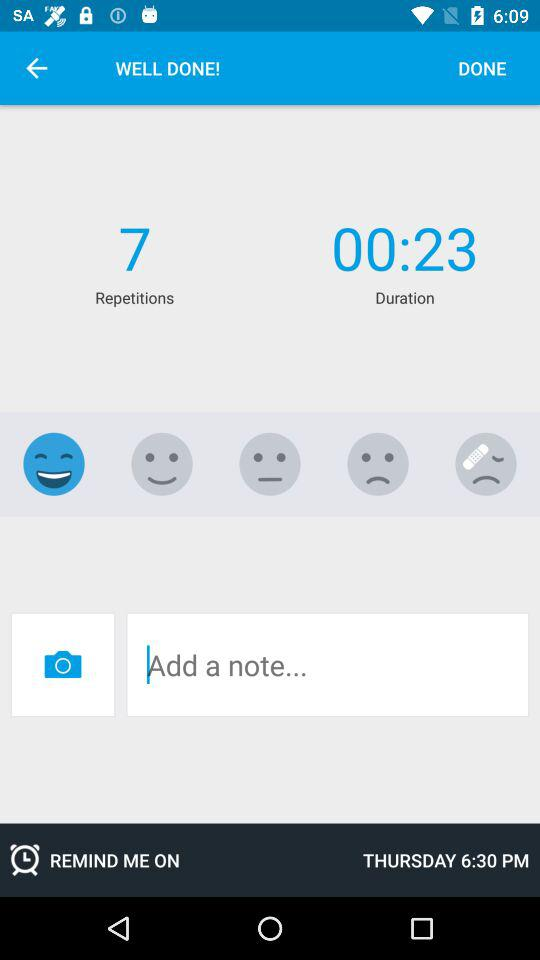How many repetitions are there?
Answer the question using a single word or phrase. 7 